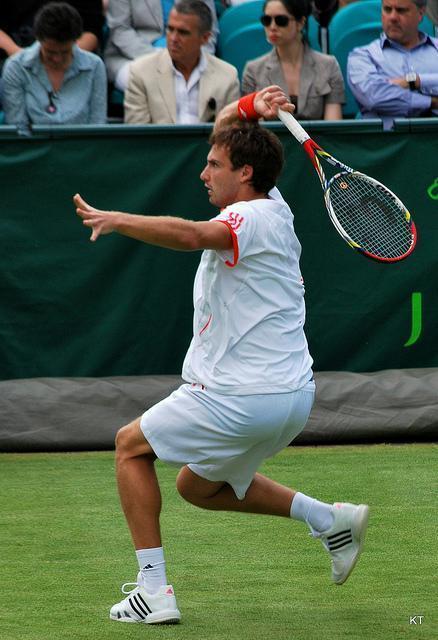How many people are visible?
Give a very brief answer. 7. How many bears are in the chair?
Give a very brief answer. 0. 